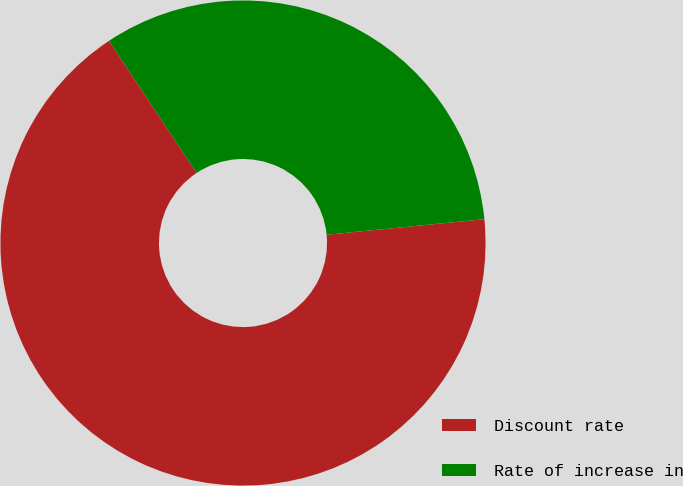Convert chart to OTSL. <chart><loc_0><loc_0><loc_500><loc_500><pie_chart><fcel>Discount rate<fcel>Rate of increase in<nl><fcel>67.26%<fcel>32.74%<nl></chart> 